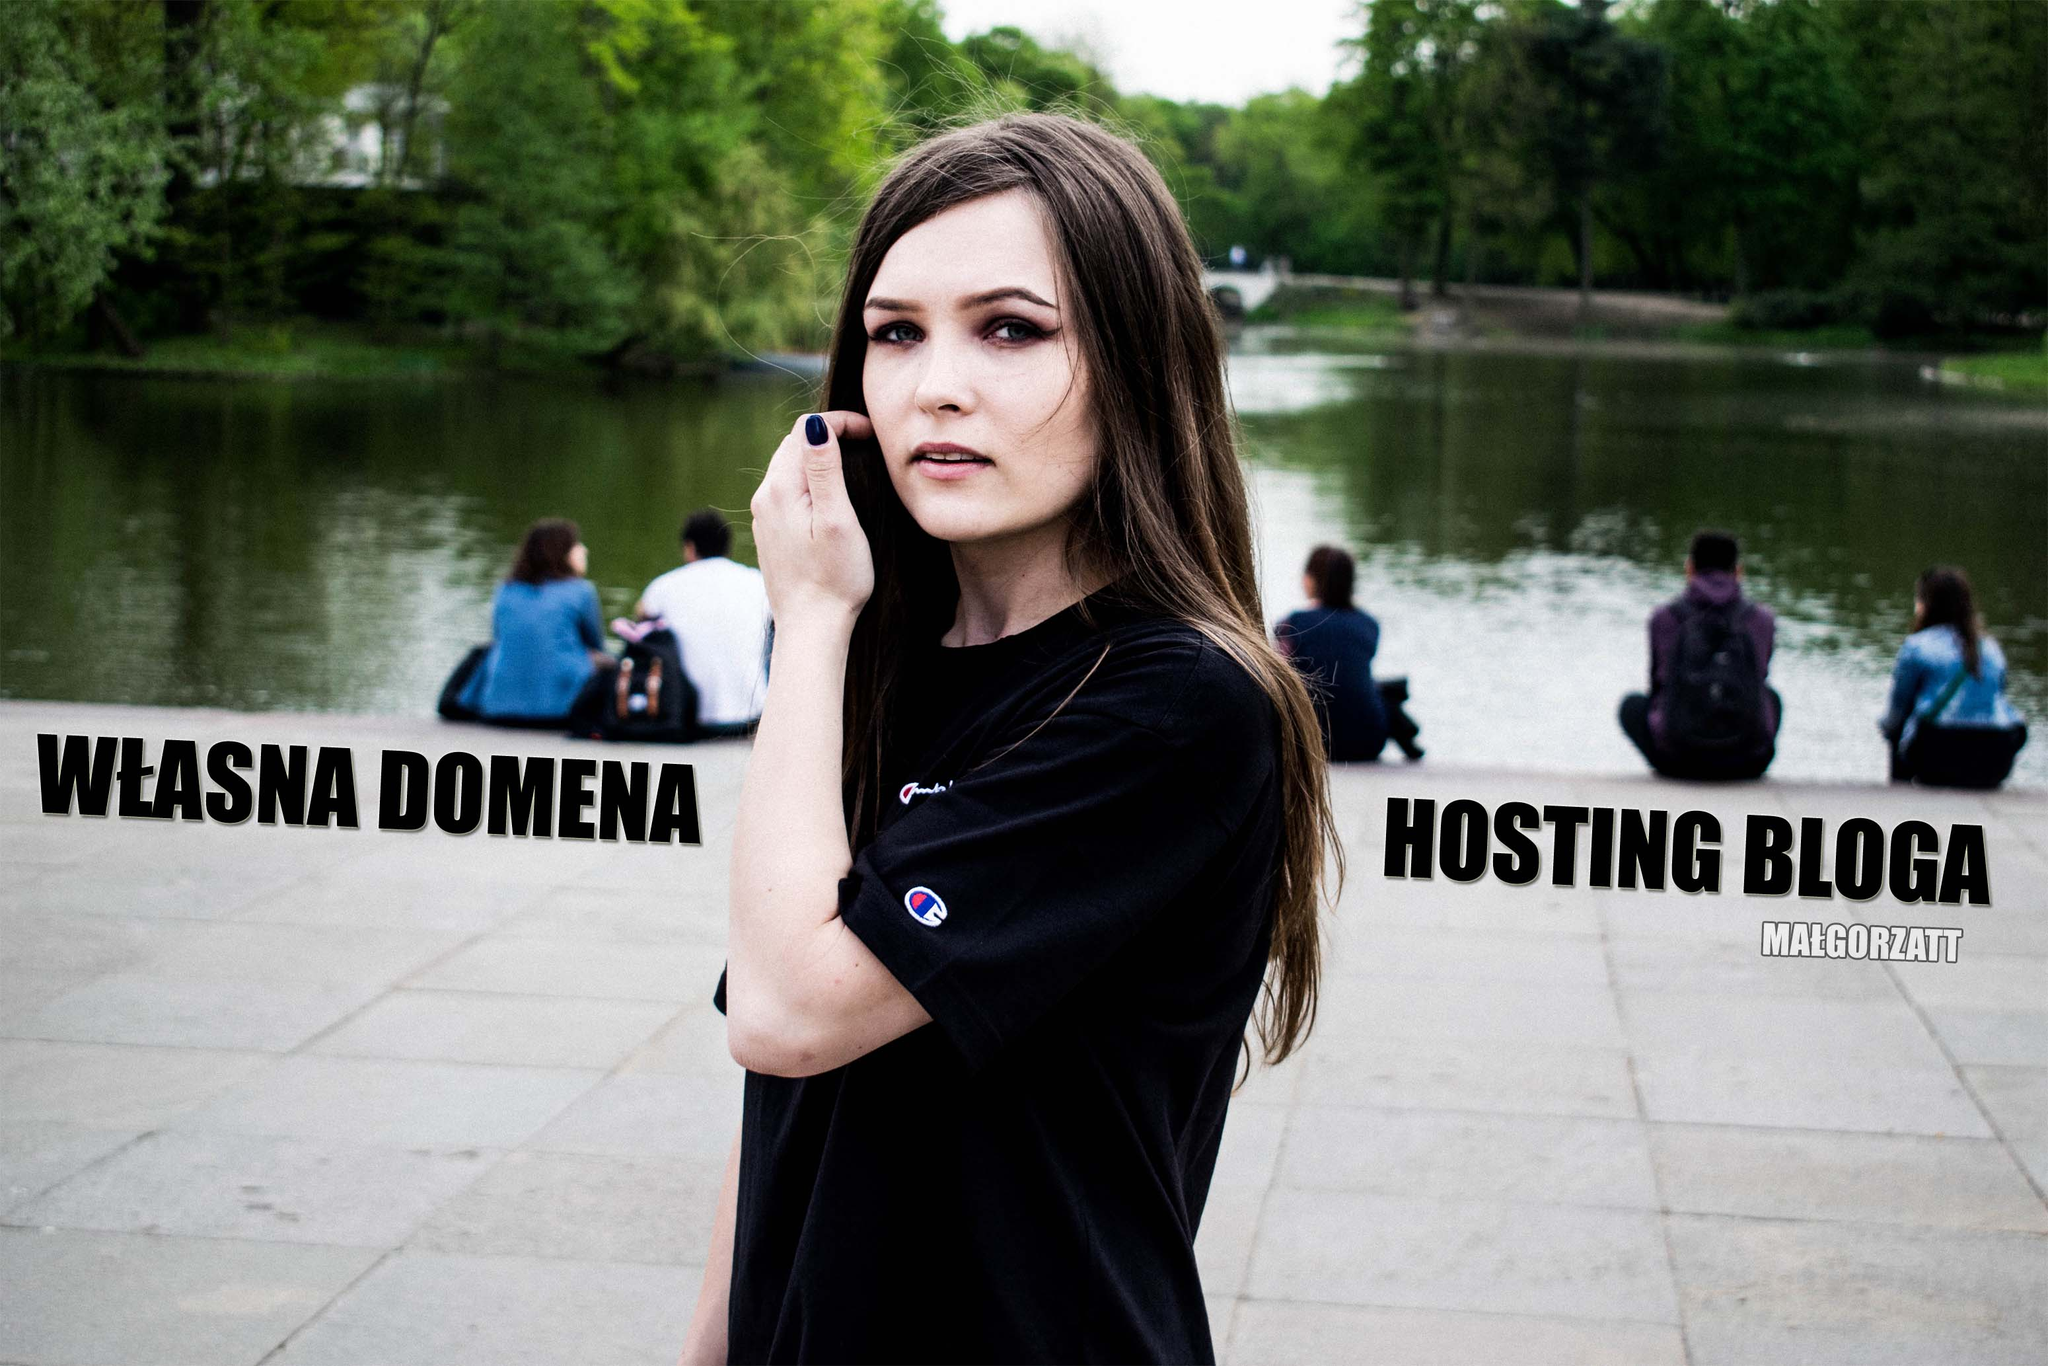Imagine the woman's perspective as she stands in the park. What might she be thinking? Standing calmly by the pond, she might be thinking about the tranquility of the park. The soft rustling of leaves and gentle lapping of water could be providing her with a moment of peace away from a hectic day. Alternatively, if she's involved in content creation, she could be contemplating her next blog post or reflecting on the effectiveness of the advertisement she's part of. What if she was daydreaming about an adventure? In her daydream, the park around her could transform into an untamed jungle brimming with exotic wildlife. The pond becomes a mystical lake, shimmering with magical creatures. She's a daring explorer, charting undiscovered lands, the text 'WŁASNA DOMENA' and 'HOSTING BLOGA' morphing into ancient inscriptions guiding her on a treasure hunt. Her casual attire shifts to that of a seasoned adventurer, equipped with a map, binoculars, and an insatiable curiosity for the unknown. 